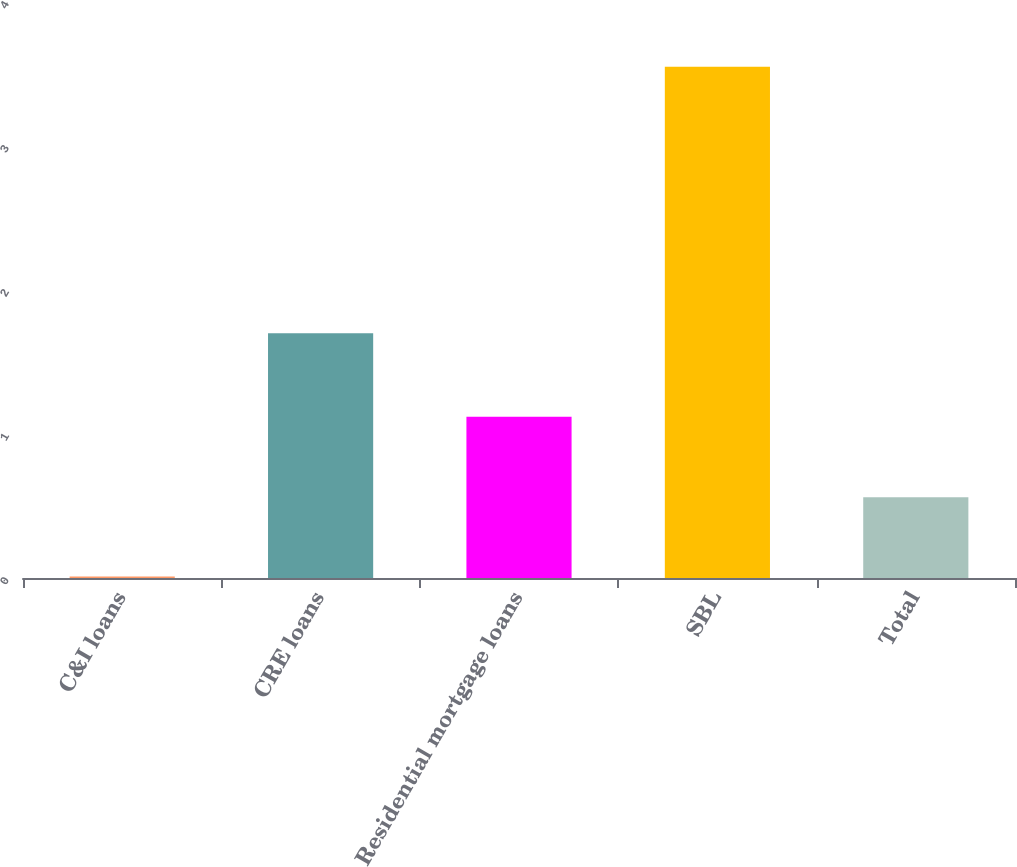Convert chart. <chart><loc_0><loc_0><loc_500><loc_500><bar_chart><fcel>C&I loans<fcel>CRE loans<fcel>Residential mortgage loans<fcel>SBL<fcel>Total<nl><fcel>0.01<fcel>1.7<fcel>1.12<fcel>3.55<fcel>0.56<nl></chart> 